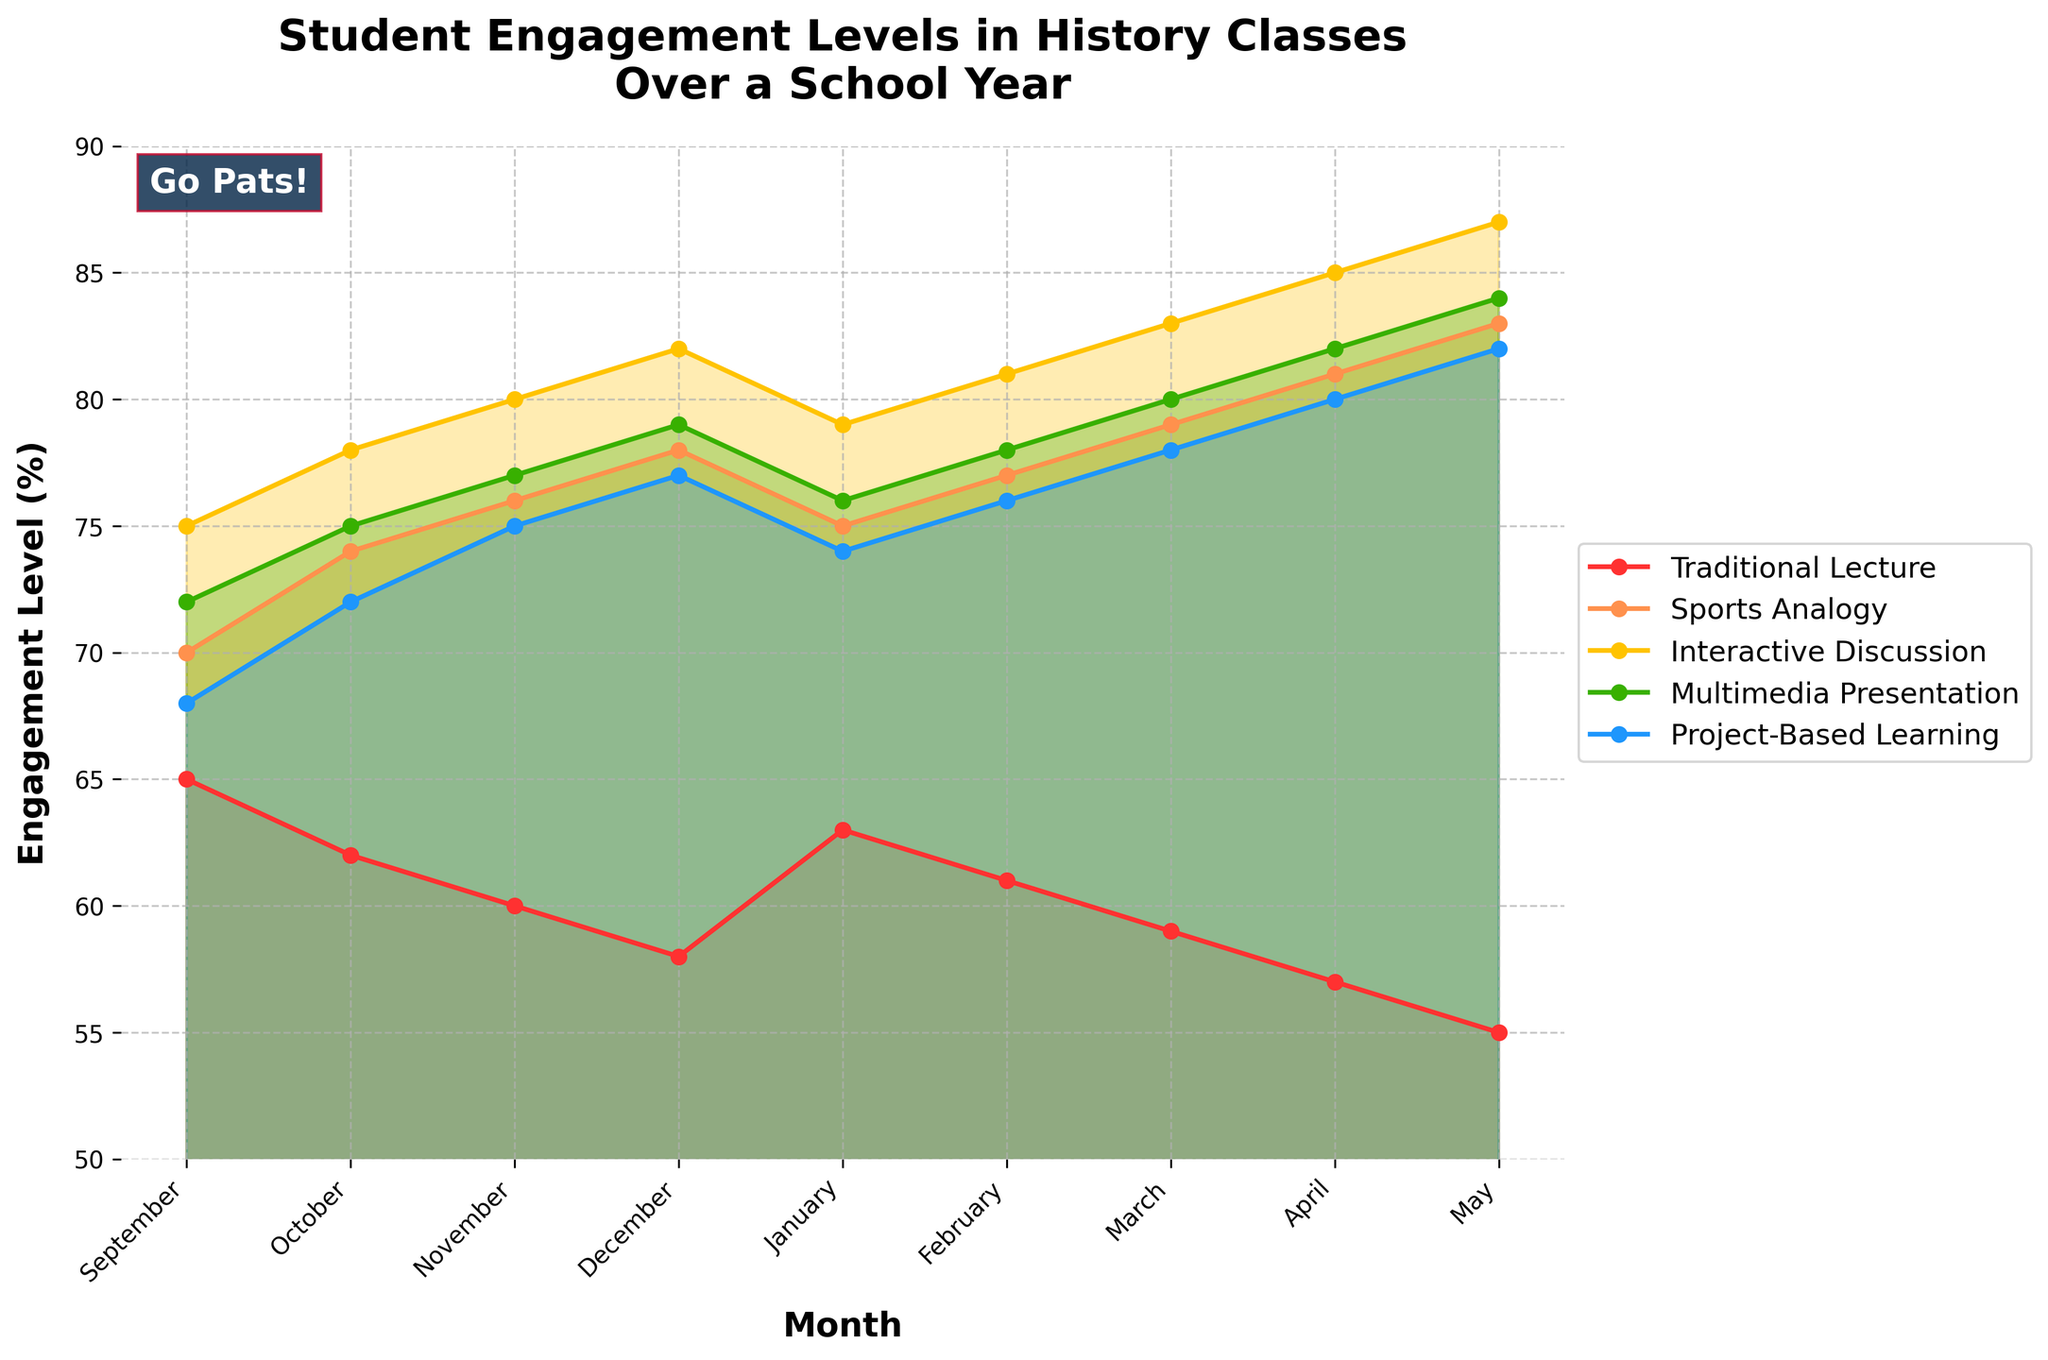Which month shows the highest student engagement level for Interactive Discussion? According to the plot, the highest engagement level for Interactive Discussion appears in May.
Answer: May Between Multimedia Presentation and Project-Based Learning, which teaching method shows a higher engagement level in March? Comparing the lines for Multimedia Presentation and Project-Based Learning in March, Project-Based Learning has a higher engagement level.
Answer: Project-Based Learning What is the trend of student engagement for Traditional Lecture from September to May? The engagement level for Traditional Lecture decreases gradually from 65% in September to 55% in May.
Answer: Decreases Calculate the average engagement level for Sports Analogy over the entire school year. Summing the engagement levels for Sports Analogy from September to May: 70 + 74 + 76 + 78 + 75 + 77 + 79 + 81 + 83 = 693. Dividing by 9 months gives an average of 77%.
Answer: 77% By how many percentage points does the engagement level for Project-Based Learning increase from September to May? The engagement level for Project-Based Learning increases from 68% in September to 82% in May. The difference is 82% - 68% = 14 percentage points.
Answer: 14 Which teaching method shows the smallest variation in engagement levels throughout the school year? Observing the plot, Traditional Lecture shows the smallest variation, remaining relatively stable around the 55-65% range.
Answer: Traditional Lecture What are the engagement levels for the Sports Analogy method in December and April, and which month is higher? The engagement level for Sports Analogy is 78% in December and 81% in April. April has a higher engagement level than December.
Answer: April Which two teaching methods have the closest engagement levels in November? Comparing the engagement levels for November, Multimedia Presentation (77%) and Project-Based Learning (75%) have the closest values. The difference is 2 percentage points.
Answer: Multimedia Presentation and Project-Based Learning How many months show engagement levels above 80% for Project-Based Learning? According to the plot, the engagement level for Project-Based Learning is above 80% in March (78%), April (80%), and May (82%). Only May is above 80%.
Answer: 1 month 